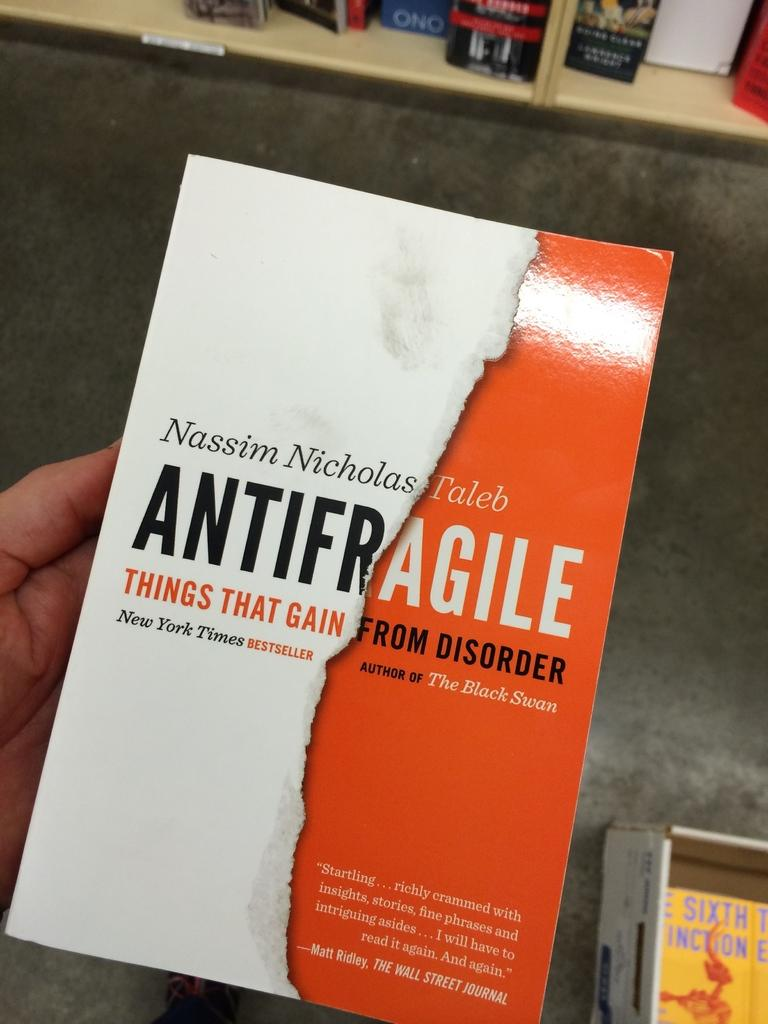<image>
Give a short and clear explanation of the subsequent image. A person is holding the book "Antifragile" in their hand. 